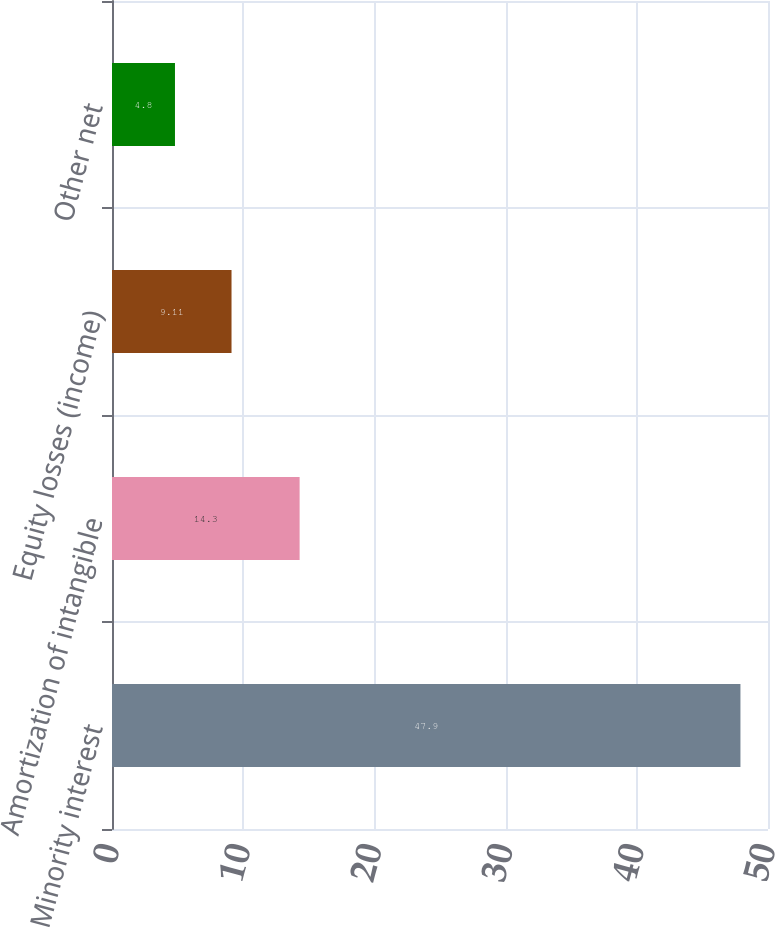<chart> <loc_0><loc_0><loc_500><loc_500><bar_chart><fcel>Minority interest<fcel>Amortization of intangible<fcel>Equity losses (income)<fcel>Other net<nl><fcel>47.9<fcel>14.3<fcel>9.11<fcel>4.8<nl></chart> 